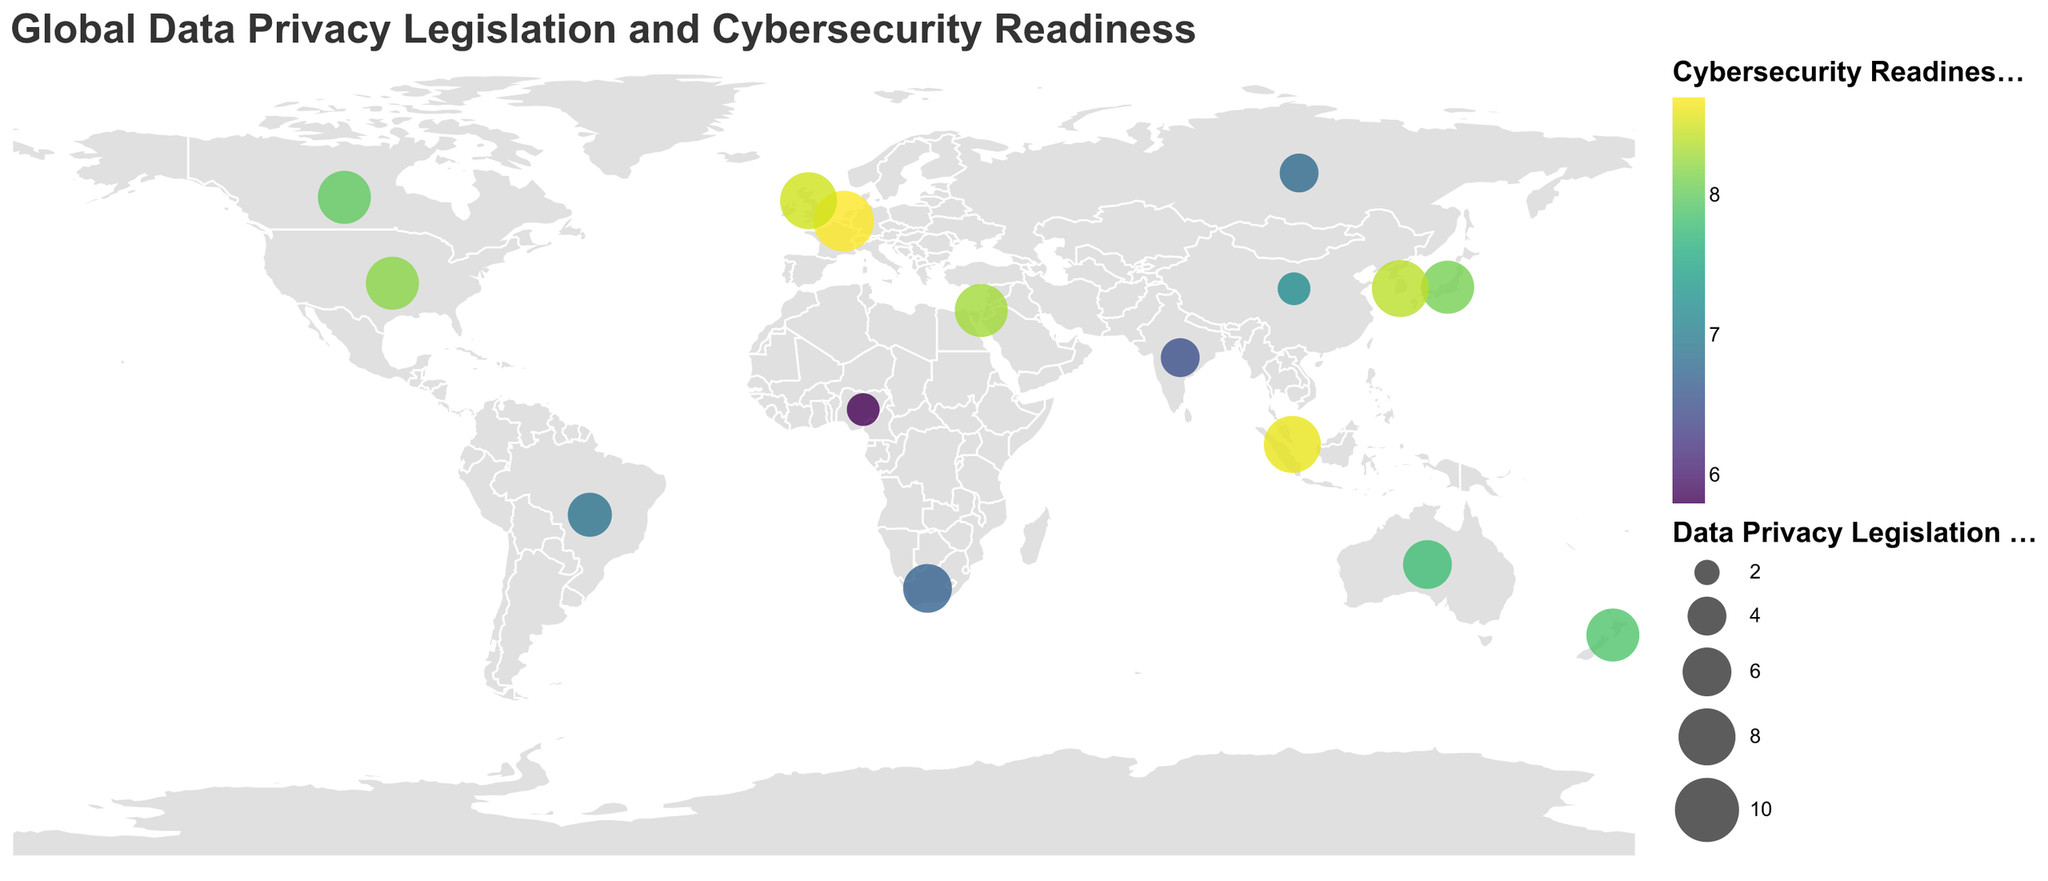What is the title of the plot? The title is displayed at the top of the plot and is stylized with specific font and color settings.
Answer: Global Data Privacy Legislation and Cybersecurity Readiness Which country has the highest Data Privacy Legislation Score? The Data Privacy Legislation Score is represented by the size of the circles. The largest circle corresponds to the European Union with a score of 9.
Answer: European Union How does the Cybersecurity Readiness Index compare between the United States and China? The index is represented by the color of the circles; the United States has a Cybersecurity Readiness Index of 8.2, while China has a score of 7.2, as indicated by their respective shades of color.
Answer: The United States has a higher Cybersecurity Readiness Index than China Which country implemented its major privacy law the earliest? By examining the tooltip information for the "Year of Major Privacy Law," Israel implemented its major privacy law in 1981, which is the earliest among the listed countries.
Answer: Israel Which countries have a Data Privacy Legislation Score of 7? By looking at the size of the circles and referencing the tooltip data, the countries with a score of 7 are the United States, Canada, Japan, Israel, and New Zealand.
Answer: United States, Canada, Japan, Israel, New Zealand How many countries have a Cybersecurity Readiness Index of 8.0 or higher? To find this, check the tooltip information to count the circles with a Cybersecurity Readiness Index of 8.0 or higher: United States, European Union, United Kingdom, Canada, South Korea, Israel, and Singapore.
Answer: 7 What is the average Data Privacy Legislation Score for countries in Asia? The relevant countries and their scores are Japan (7), South Korea (8), China (3), India (4), Israel (7), and Singapore (8). The average is (7 + 8 + 3 + 4 + 7 + 8) / 6 = 6.1667.
Answer: 6.1667 Which country has the lowest Cybersecurity Readiness Index, and what is that value? Nigeria has the lowest Cybersecurity Readiness Index with a value of 5.8, as shown in the tooltip data.
Answer: Nigeria, 5.8 What is the difference in the Data Privacy Legislation Score between Brazil and Australia? The scores are Brazil (5) and Australia (6). The difference is 6 - 5 = 1.
Answer: 1 Which countries enacted their major privacy law in 2018? By checking the tooltip data for the "Year of Major Privacy Law," the countries are the United States, European Union, United Kingdom, and Brazil.
Answer: United States, European Union, United Kingdom, Brazil 